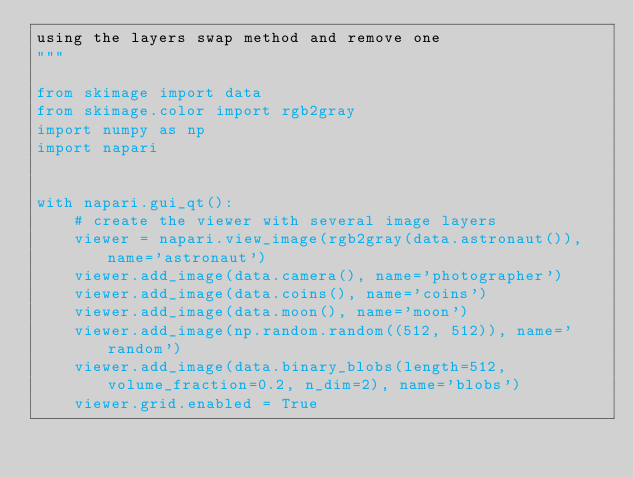Convert code to text. <code><loc_0><loc_0><loc_500><loc_500><_Python_>using the layers swap method and remove one
"""

from skimage import data
from skimage.color import rgb2gray
import numpy as np
import napari


with napari.gui_qt():
    # create the viewer with several image layers
    viewer = napari.view_image(rgb2gray(data.astronaut()), name='astronaut')
    viewer.add_image(data.camera(), name='photographer')
    viewer.add_image(data.coins(), name='coins')
    viewer.add_image(data.moon(), name='moon')
    viewer.add_image(np.random.random((512, 512)), name='random')
    viewer.add_image(data.binary_blobs(length=512, volume_fraction=0.2, n_dim=2), name='blobs')
    viewer.grid.enabled = True
</code> 